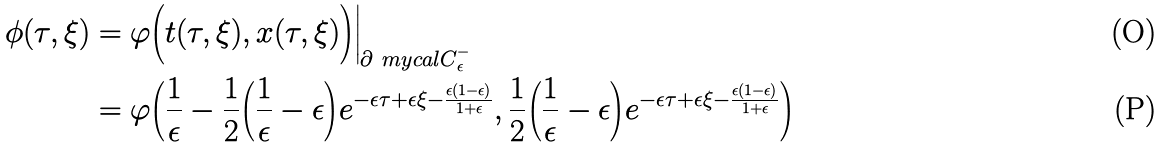Convert formula to latex. <formula><loc_0><loc_0><loc_500><loc_500>\phi ( \tau , \xi ) & = \varphi \Big ( t ( \tau , \xi ) , x ( \tau , \xi ) \Big ) \Big | _ { \partial { \ m y c a l C } _ { \epsilon } ^ { - } } \\ & = \varphi \Big ( \frac { 1 } { \epsilon } - \frac { 1 } { 2 } \Big ( \frac { 1 } { \epsilon } - \epsilon \Big ) e ^ { - \epsilon \tau + \epsilon \xi - \frac { \epsilon ( 1 - \epsilon ) } { 1 + \epsilon } } , \frac { 1 } { 2 } \Big ( \frac { 1 } { \epsilon } - \epsilon \Big ) e ^ { - \epsilon \tau + \epsilon \xi - \frac { \epsilon ( 1 - \epsilon ) } { 1 + \epsilon } } \Big )</formula> 